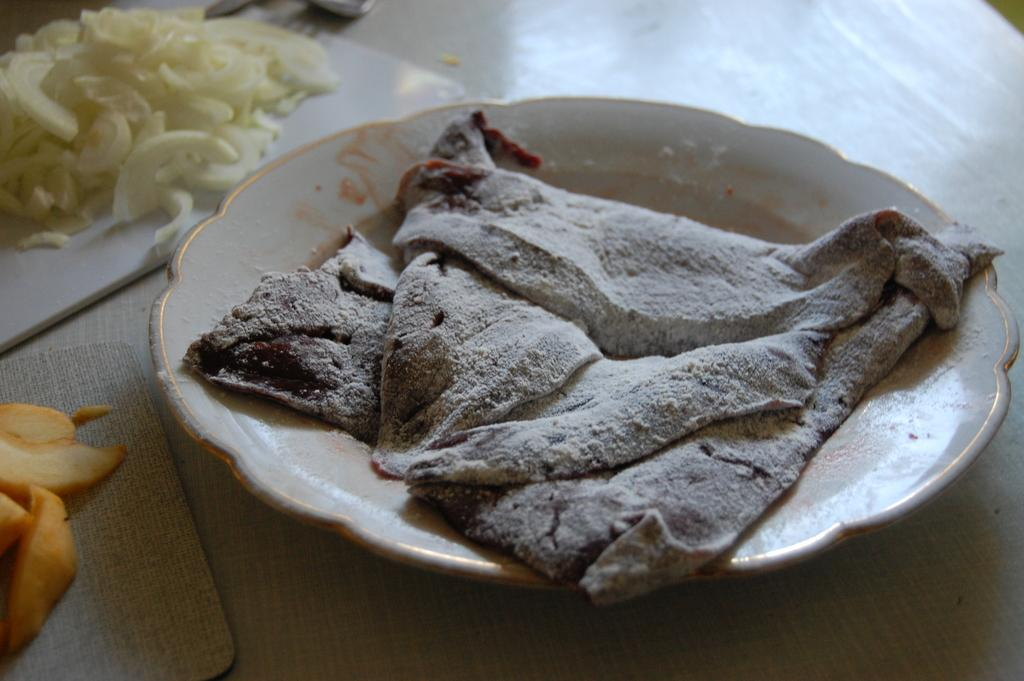What type of food can be seen on the plate in the image? The type of food on the plate cannot be determined from the provided facts. What other food items are visible in the image? There is additional food placed on trays in the image. What is the surface on which the plate and trays are placed? The plate and trays are on a wooden table. How many oranges are being used to support the wooden table in the image? There are no oranges present in the image, and they are not being used to support the wooden table. What type of beam is holding up the ceiling in the image? There is no information about a ceiling or any beams in the image. 